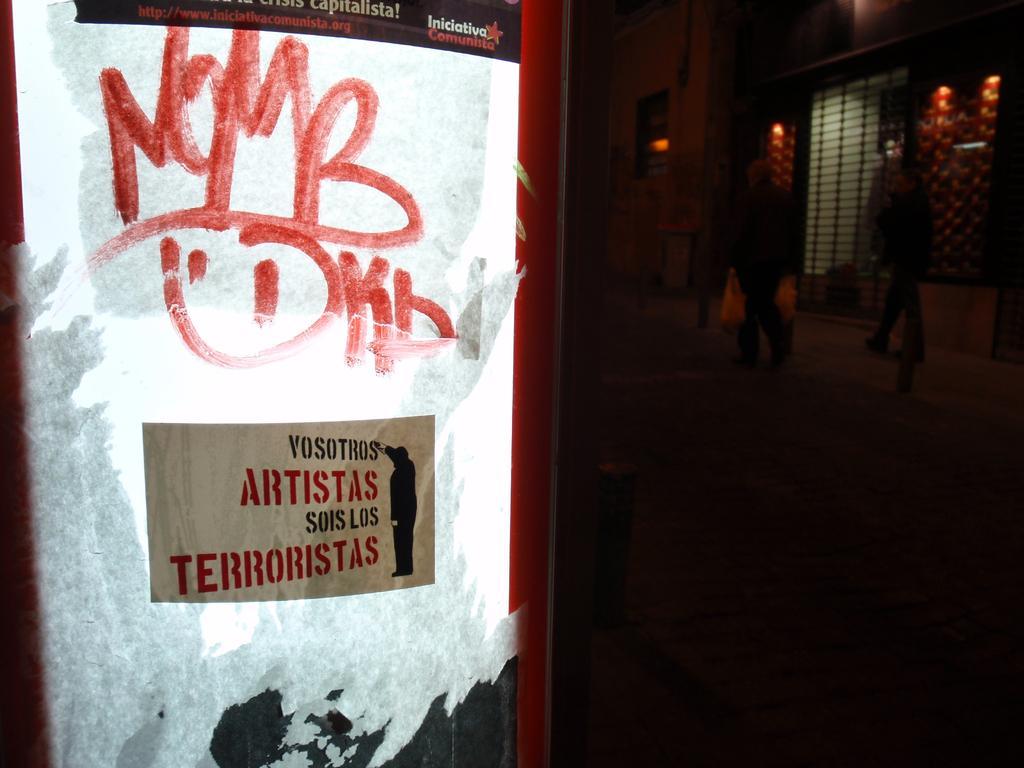Describe this image in one or two sentences. In this image in the foreground there is one glass door and some text is written on the door, and also there is one poster. On the door on the right side there are some people who are walking and there is a wall and a gate. 